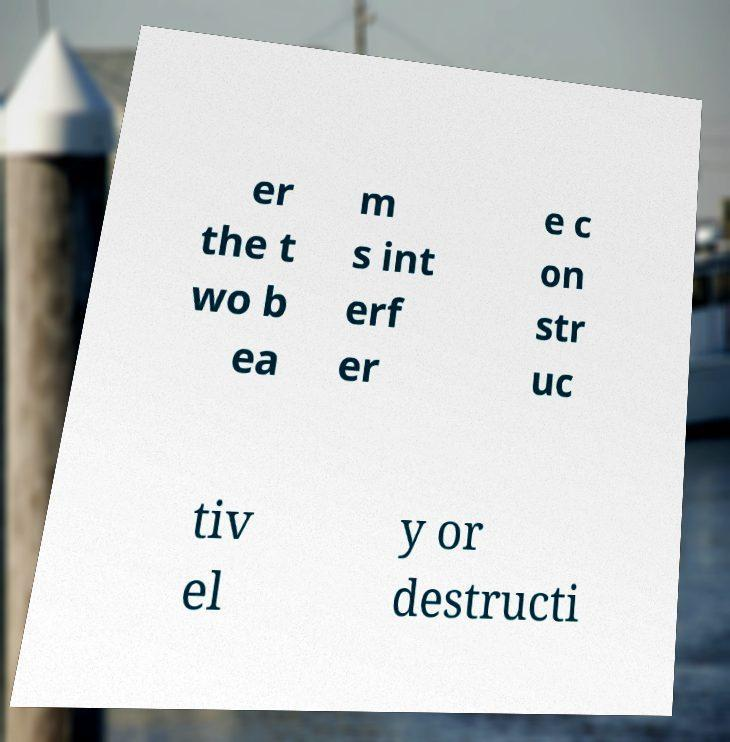For documentation purposes, I need the text within this image transcribed. Could you provide that? er the t wo b ea m s int erf er e c on str uc tiv el y or destructi 